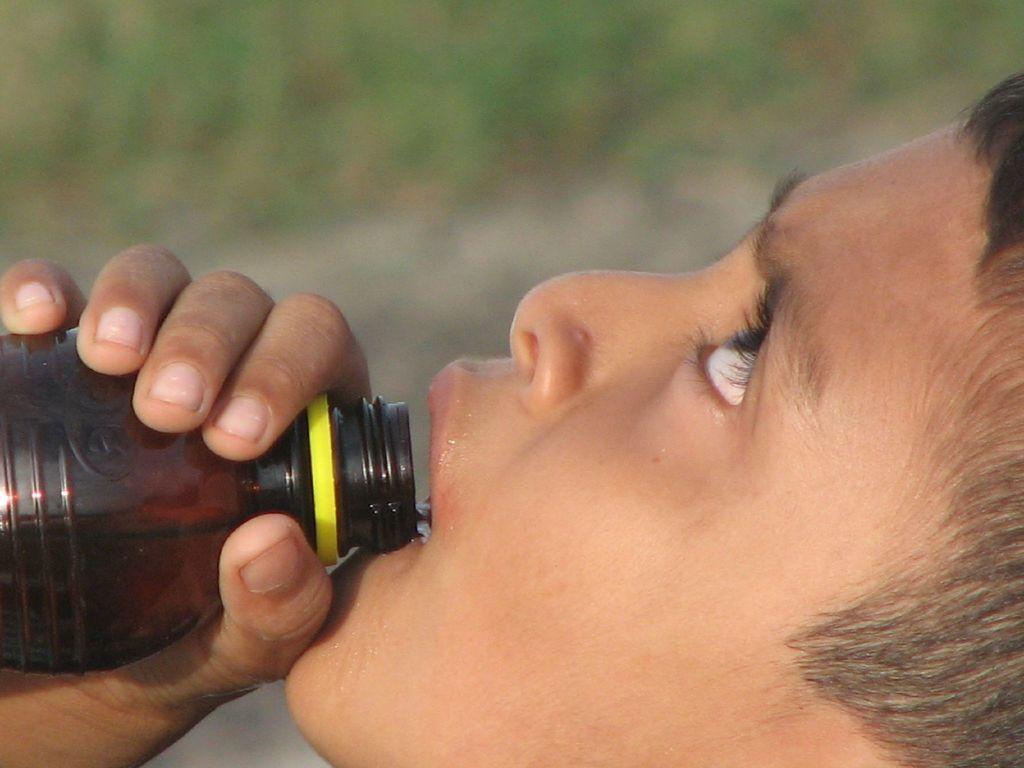In one or two sentences, can you explain what this image depicts? This image consists of a person drinking water. To the left, there is a bottle in black color. In the background, there are trees and the background is blurred. 